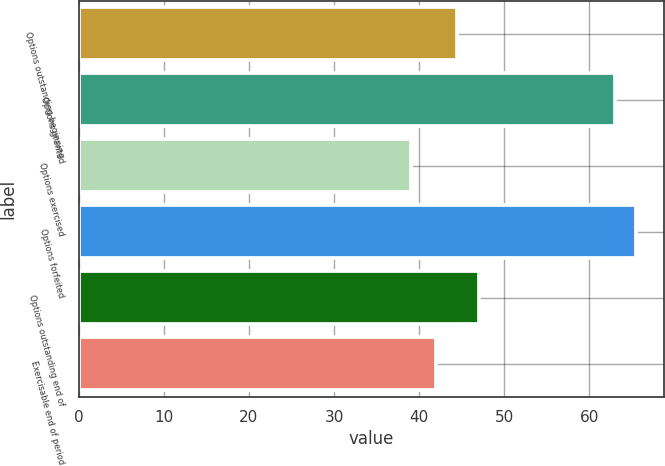Convert chart. <chart><loc_0><loc_0><loc_500><loc_500><bar_chart><fcel>Options outstanding beginning<fcel>Options granted<fcel>Options exercised<fcel>Options forfeited<fcel>Options outstanding end of<fcel>Exercisable end of period<nl><fcel>44.5<fcel>63<fcel>39<fcel>65.5<fcel>47<fcel>42<nl></chart> 